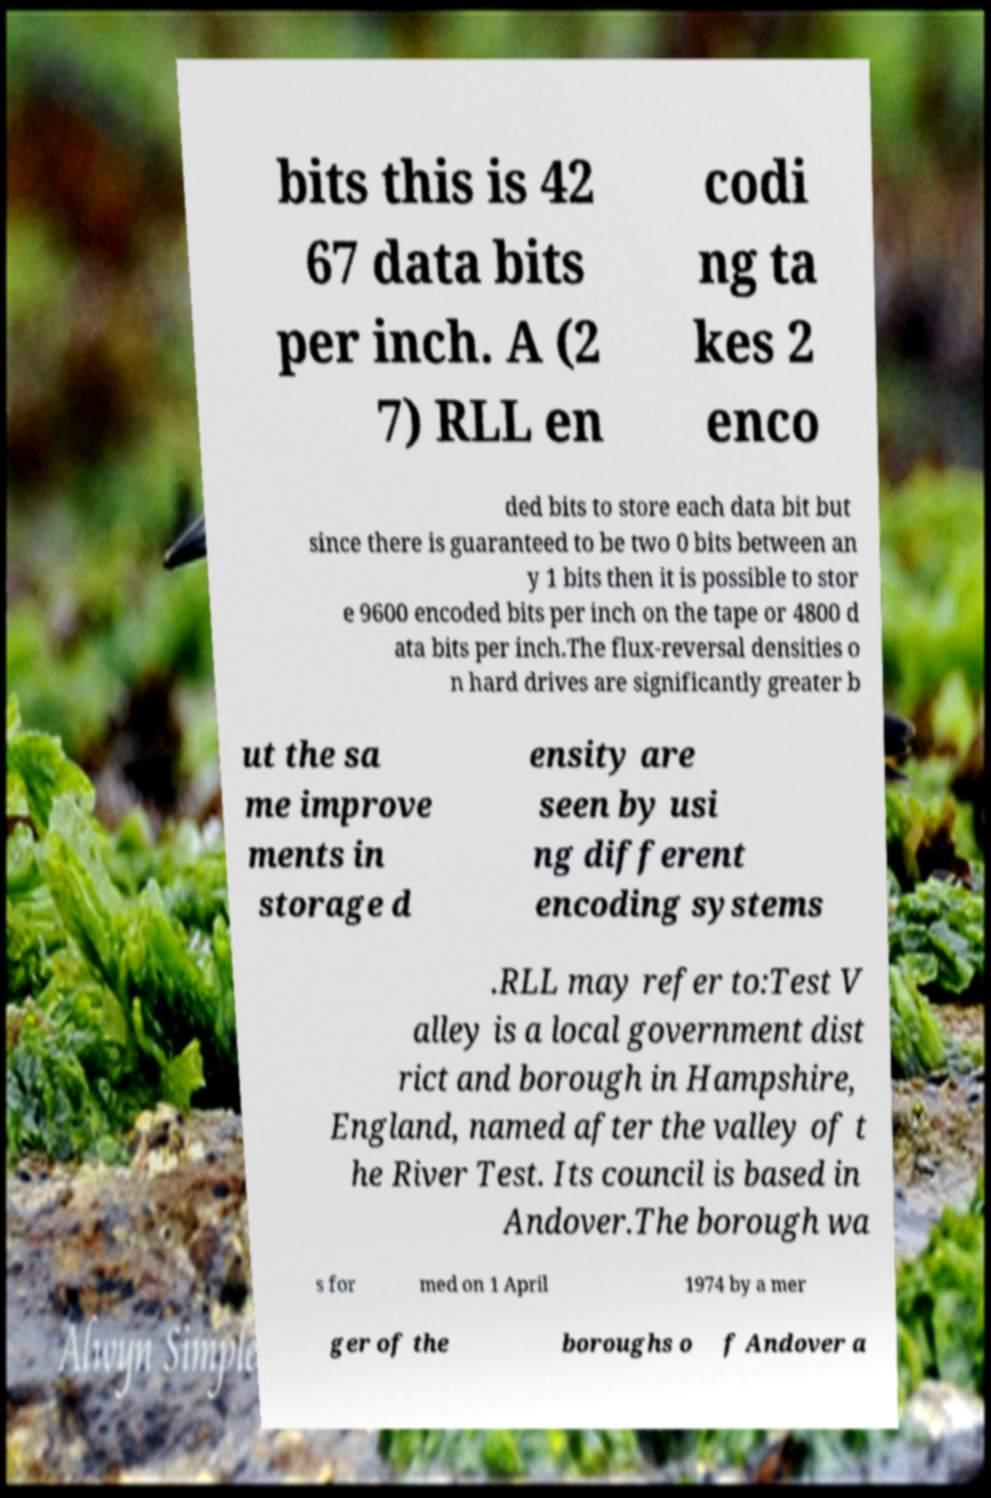Could you assist in decoding the text presented in this image and type it out clearly? bits this is 42 67 data bits per inch. A (2 7) RLL en codi ng ta kes 2 enco ded bits to store each data bit but since there is guaranteed to be two 0 bits between an y 1 bits then it is possible to stor e 9600 encoded bits per inch on the tape or 4800 d ata bits per inch.The flux-reversal densities o n hard drives are significantly greater b ut the sa me improve ments in storage d ensity are seen by usi ng different encoding systems .RLL may refer to:Test V alley is a local government dist rict and borough in Hampshire, England, named after the valley of t he River Test. Its council is based in Andover.The borough wa s for med on 1 April 1974 by a mer ger of the boroughs o f Andover a 